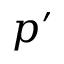<formula> <loc_0><loc_0><loc_500><loc_500>p ^ { \prime }</formula> 